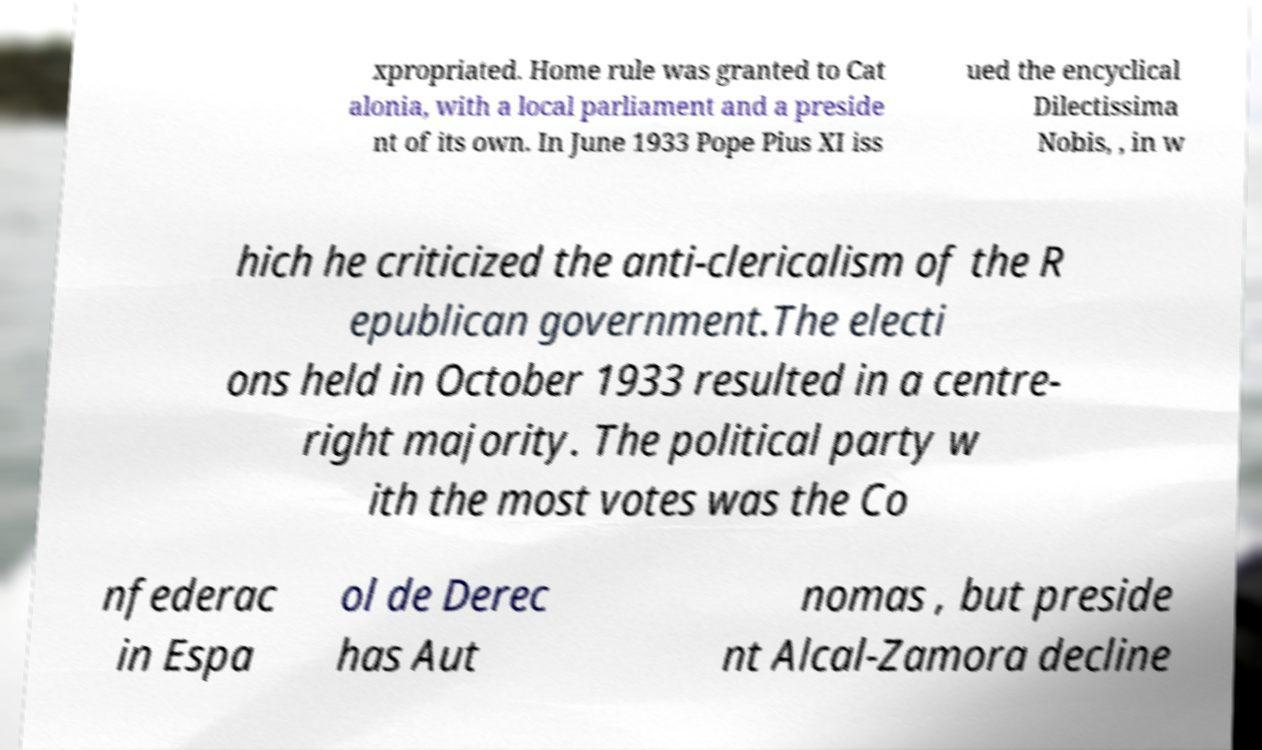There's text embedded in this image that I need extracted. Can you transcribe it verbatim? xpropriated. Home rule was granted to Cat alonia, with a local parliament and a preside nt of its own. In June 1933 Pope Pius XI iss ued the encyclical Dilectissima Nobis, , in w hich he criticized the anti-clericalism of the R epublican government.The electi ons held in October 1933 resulted in a centre- right majority. The political party w ith the most votes was the Co nfederac in Espa ol de Derec has Aut nomas , but preside nt Alcal-Zamora decline 